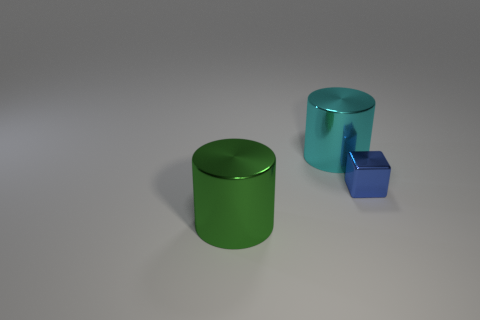Add 2 green cubes. How many objects exist? 5 Subtract all blocks. How many objects are left? 2 Subtract all large objects. Subtract all large green objects. How many objects are left? 0 Add 3 metallic objects. How many metallic objects are left? 6 Add 2 yellow things. How many yellow things exist? 2 Subtract 0 brown balls. How many objects are left? 3 